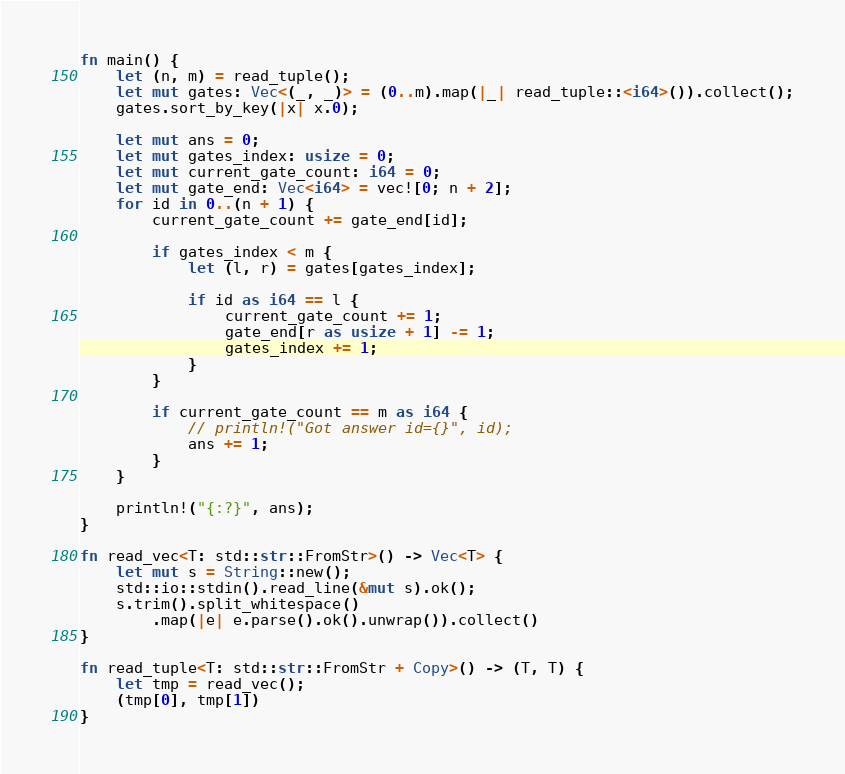<code> <loc_0><loc_0><loc_500><loc_500><_Rust_>fn main() {
    let (n, m) = read_tuple();
    let mut gates: Vec<(_, _)> = (0..m).map(|_| read_tuple::<i64>()).collect();
    gates.sort_by_key(|x| x.0);

    let mut ans = 0;
    let mut gates_index: usize = 0;
    let mut current_gate_count: i64 = 0;
    let mut gate_end: Vec<i64> = vec![0; n + 2];
    for id in 0..(n + 1) {
        current_gate_count += gate_end[id];

        if gates_index < m {
            let (l, r) = gates[gates_index];

            if id as i64 == l {
                current_gate_count += 1;
                gate_end[r as usize + 1] -= 1;
                gates_index += 1;
            }
        }

        if current_gate_count == m as i64 {
            // println!("Got answer id={}", id);
            ans += 1;
        }
    }

    println!("{:?}", ans);
}

fn read_vec<T: std::str::FromStr>() -> Vec<T> {
    let mut s = String::new();
    std::io::stdin().read_line(&mut s).ok();
    s.trim().split_whitespace()
        .map(|e| e.parse().ok().unwrap()).collect()
}

fn read_tuple<T: std::str::FromStr + Copy>() -> (T, T) {
    let tmp = read_vec();
    (tmp[0], tmp[1])
}</code> 